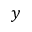Convert formula to latex. <formula><loc_0><loc_0><loc_500><loc_500>y</formula> 